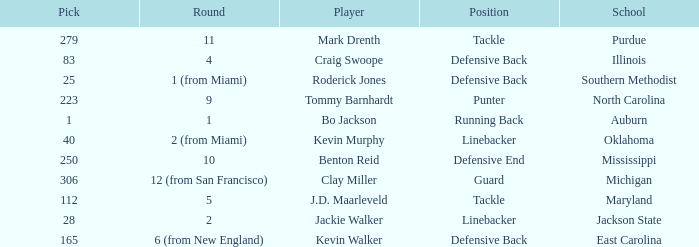What is the highest pick for a player from auburn? 1.0. 